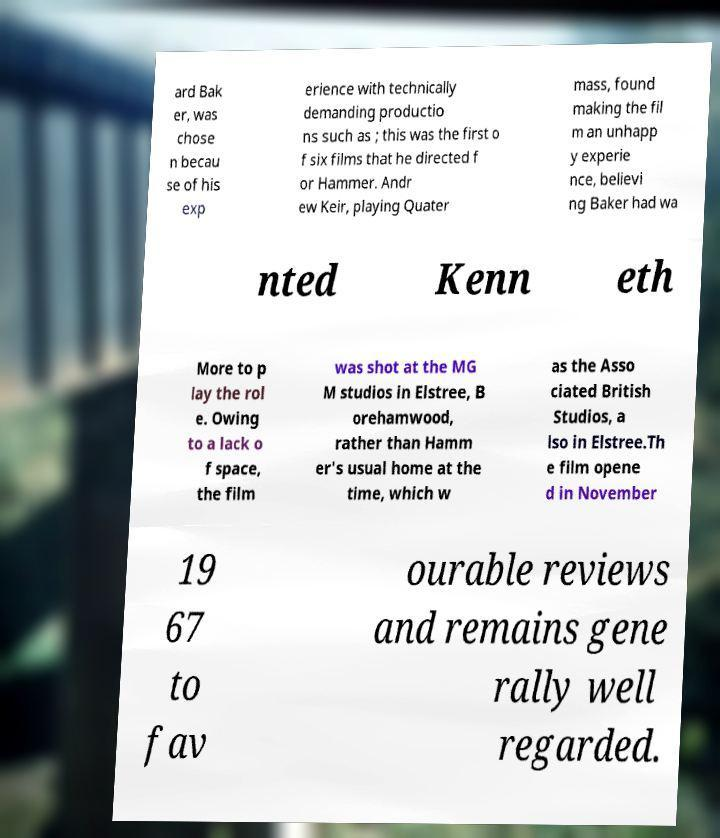I need the written content from this picture converted into text. Can you do that? ard Bak er, was chose n becau se of his exp erience with technically demanding productio ns such as ; this was the first o f six films that he directed f or Hammer. Andr ew Keir, playing Quater mass, found making the fil m an unhapp y experie nce, believi ng Baker had wa nted Kenn eth More to p lay the rol e. Owing to a lack o f space, the film was shot at the MG M studios in Elstree, B orehamwood, rather than Hamm er's usual home at the time, which w as the Asso ciated British Studios, a lso in Elstree.Th e film opene d in November 19 67 to fav ourable reviews and remains gene rally well regarded. 